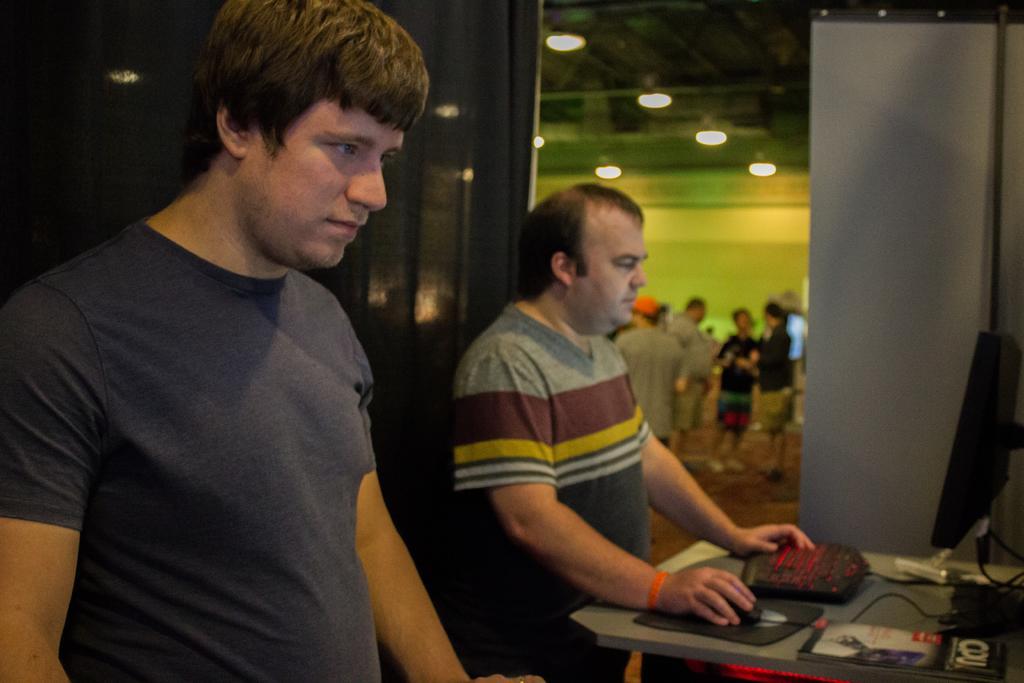How would you summarize this image in a sentence or two? In this picture i can see two persons are standing. The person on the right side is operating a mouse and keyboard which is on the table. I can also see some other objects on the table. In the background I can see people are standing and lights. 